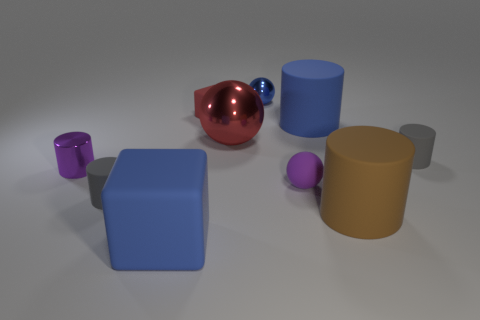Are there any small yellow cylinders?
Your answer should be very brief. No. What is the shape of the small blue object that is made of the same material as the red ball?
Your response must be concise. Sphere. What is the color of the block in front of the gray matte cylinder right of the shiny object that is behind the big red object?
Your answer should be very brief. Blue. Is the number of gray matte things that are behind the small purple cylinder the same as the number of large green shiny cubes?
Provide a short and direct response. No. Does the large ball have the same color as the cube behind the blue rubber cylinder?
Offer a very short reply. Yes. There is a metal ball that is in front of the tiny thing that is behind the small red cube; are there any matte cylinders that are in front of it?
Your answer should be compact. Yes. Is the number of small cylinders left of the blue metallic thing less than the number of purple balls?
Make the answer very short. No. What number of other objects are there of the same shape as the blue shiny thing?
Make the answer very short. 2. How many objects are either tiny purple things that are on the right side of the red matte thing or tiny rubber things left of the rubber ball?
Ensure brevity in your answer.  3. What size is the blue thing that is in front of the red cube and behind the brown matte object?
Provide a succinct answer. Large. 